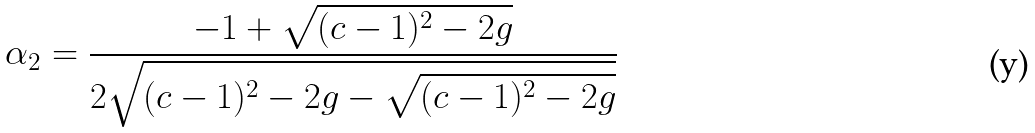Convert formula to latex. <formula><loc_0><loc_0><loc_500><loc_500>\alpha _ { 2 } = \frac { - 1 + \sqrt { ( c - 1 ) ^ { 2 } - 2 g } } { 2 \sqrt { ( c - 1 ) ^ { 2 } - 2 g - \sqrt { ( c - 1 ) ^ { 2 } - 2 g } } }</formula> 